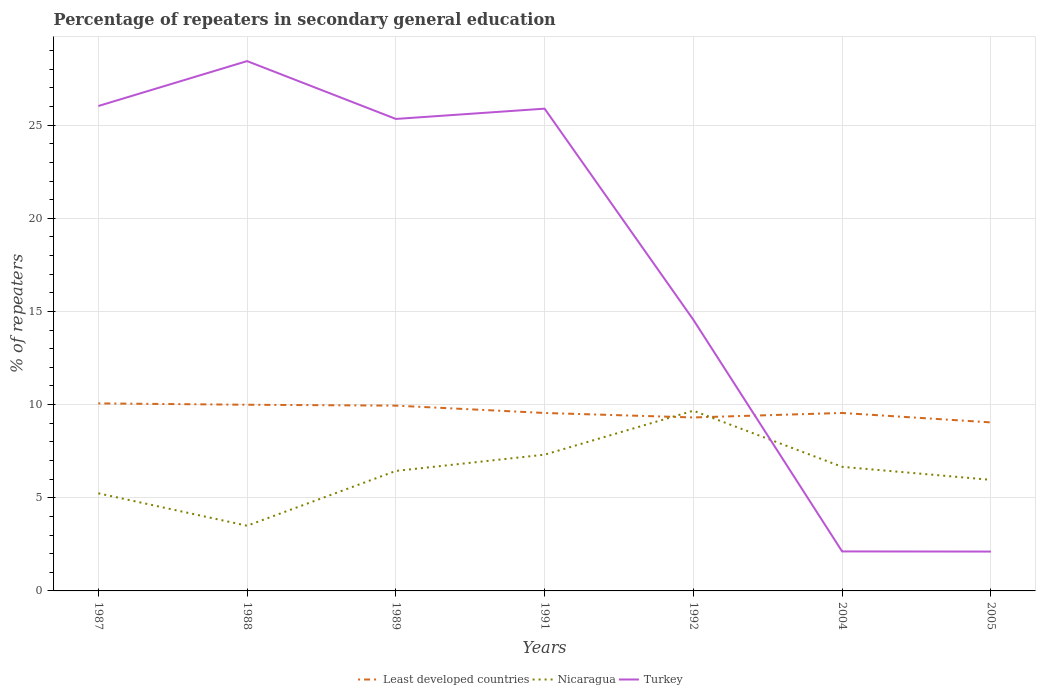How many different coloured lines are there?
Offer a very short reply. 3. Does the line corresponding to Least developed countries intersect with the line corresponding to Nicaragua?
Keep it short and to the point. Yes. Is the number of lines equal to the number of legend labels?
Provide a short and direct response. Yes. Across all years, what is the maximum percentage of repeaters in secondary general education in Turkey?
Your answer should be compact. 2.11. What is the total percentage of repeaters in secondary general education in Turkey in the graph?
Your response must be concise. 0.69. What is the difference between the highest and the second highest percentage of repeaters in secondary general education in Least developed countries?
Provide a short and direct response. 1.02. How many lines are there?
Offer a very short reply. 3. What is the difference between two consecutive major ticks on the Y-axis?
Your response must be concise. 5. Does the graph contain any zero values?
Offer a terse response. No. Does the graph contain grids?
Provide a short and direct response. Yes. Where does the legend appear in the graph?
Your response must be concise. Bottom center. What is the title of the graph?
Ensure brevity in your answer.  Percentage of repeaters in secondary general education. What is the label or title of the Y-axis?
Your answer should be compact. % of repeaters. What is the % of repeaters in Least developed countries in 1987?
Provide a succinct answer. 10.06. What is the % of repeaters of Nicaragua in 1987?
Provide a short and direct response. 5.24. What is the % of repeaters of Turkey in 1987?
Ensure brevity in your answer.  26.03. What is the % of repeaters of Least developed countries in 1988?
Make the answer very short. 9.99. What is the % of repeaters of Nicaragua in 1988?
Provide a succinct answer. 3.5. What is the % of repeaters of Turkey in 1988?
Give a very brief answer. 28.44. What is the % of repeaters in Least developed countries in 1989?
Provide a succinct answer. 9.94. What is the % of repeaters of Nicaragua in 1989?
Give a very brief answer. 6.44. What is the % of repeaters in Turkey in 1989?
Offer a terse response. 25.33. What is the % of repeaters of Least developed countries in 1991?
Your answer should be very brief. 9.55. What is the % of repeaters of Nicaragua in 1991?
Provide a short and direct response. 7.31. What is the % of repeaters in Turkey in 1991?
Offer a very short reply. 25.88. What is the % of repeaters in Least developed countries in 1992?
Offer a terse response. 9.31. What is the % of repeaters in Nicaragua in 1992?
Ensure brevity in your answer.  9.67. What is the % of repeaters of Turkey in 1992?
Provide a succinct answer. 14.55. What is the % of repeaters of Least developed countries in 2004?
Offer a very short reply. 9.55. What is the % of repeaters of Nicaragua in 2004?
Make the answer very short. 6.66. What is the % of repeaters of Turkey in 2004?
Your response must be concise. 2.12. What is the % of repeaters in Least developed countries in 2005?
Provide a short and direct response. 9.04. What is the % of repeaters in Nicaragua in 2005?
Make the answer very short. 5.96. What is the % of repeaters in Turkey in 2005?
Your answer should be very brief. 2.11. Across all years, what is the maximum % of repeaters of Least developed countries?
Your response must be concise. 10.06. Across all years, what is the maximum % of repeaters in Nicaragua?
Offer a terse response. 9.67. Across all years, what is the maximum % of repeaters in Turkey?
Provide a short and direct response. 28.44. Across all years, what is the minimum % of repeaters of Least developed countries?
Provide a short and direct response. 9.04. Across all years, what is the minimum % of repeaters in Nicaragua?
Your answer should be very brief. 3.5. Across all years, what is the minimum % of repeaters of Turkey?
Provide a succinct answer. 2.11. What is the total % of repeaters of Least developed countries in the graph?
Give a very brief answer. 67.46. What is the total % of repeaters of Nicaragua in the graph?
Your response must be concise. 44.78. What is the total % of repeaters of Turkey in the graph?
Ensure brevity in your answer.  124.46. What is the difference between the % of repeaters in Least developed countries in 1987 and that in 1988?
Give a very brief answer. 0.07. What is the difference between the % of repeaters of Nicaragua in 1987 and that in 1988?
Your answer should be compact. 1.74. What is the difference between the % of repeaters of Turkey in 1987 and that in 1988?
Give a very brief answer. -2.41. What is the difference between the % of repeaters in Least developed countries in 1987 and that in 1989?
Offer a terse response. 0.12. What is the difference between the % of repeaters of Nicaragua in 1987 and that in 1989?
Your answer should be compact. -1.2. What is the difference between the % of repeaters of Turkey in 1987 and that in 1989?
Your answer should be compact. 0.69. What is the difference between the % of repeaters of Least developed countries in 1987 and that in 1991?
Offer a very short reply. 0.51. What is the difference between the % of repeaters in Nicaragua in 1987 and that in 1991?
Your answer should be compact. -2.07. What is the difference between the % of repeaters in Turkey in 1987 and that in 1991?
Keep it short and to the point. 0.14. What is the difference between the % of repeaters of Least developed countries in 1987 and that in 1992?
Your answer should be compact. 0.75. What is the difference between the % of repeaters in Nicaragua in 1987 and that in 1992?
Your response must be concise. -4.43. What is the difference between the % of repeaters of Turkey in 1987 and that in 1992?
Provide a short and direct response. 11.47. What is the difference between the % of repeaters of Least developed countries in 1987 and that in 2004?
Keep it short and to the point. 0.51. What is the difference between the % of repeaters of Nicaragua in 1987 and that in 2004?
Make the answer very short. -1.42. What is the difference between the % of repeaters of Turkey in 1987 and that in 2004?
Offer a terse response. 23.91. What is the difference between the % of repeaters in Least developed countries in 1987 and that in 2005?
Provide a succinct answer. 1.02. What is the difference between the % of repeaters of Nicaragua in 1987 and that in 2005?
Your answer should be compact. -0.72. What is the difference between the % of repeaters in Turkey in 1987 and that in 2005?
Keep it short and to the point. 23.91. What is the difference between the % of repeaters of Least developed countries in 1988 and that in 1989?
Offer a terse response. 0.05. What is the difference between the % of repeaters in Nicaragua in 1988 and that in 1989?
Your answer should be compact. -2.94. What is the difference between the % of repeaters of Turkey in 1988 and that in 1989?
Provide a succinct answer. 3.1. What is the difference between the % of repeaters in Least developed countries in 1988 and that in 1991?
Ensure brevity in your answer.  0.44. What is the difference between the % of repeaters of Nicaragua in 1988 and that in 1991?
Offer a very short reply. -3.81. What is the difference between the % of repeaters in Turkey in 1988 and that in 1991?
Your response must be concise. 2.55. What is the difference between the % of repeaters of Least developed countries in 1988 and that in 1992?
Provide a succinct answer. 0.68. What is the difference between the % of repeaters of Nicaragua in 1988 and that in 1992?
Give a very brief answer. -6.17. What is the difference between the % of repeaters of Turkey in 1988 and that in 1992?
Give a very brief answer. 13.88. What is the difference between the % of repeaters in Least developed countries in 1988 and that in 2004?
Your answer should be compact. 0.44. What is the difference between the % of repeaters of Nicaragua in 1988 and that in 2004?
Your answer should be very brief. -3.16. What is the difference between the % of repeaters in Turkey in 1988 and that in 2004?
Ensure brevity in your answer.  26.32. What is the difference between the % of repeaters in Least developed countries in 1988 and that in 2005?
Provide a short and direct response. 0.95. What is the difference between the % of repeaters of Nicaragua in 1988 and that in 2005?
Your answer should be very brief. -2.46. What is the difference between the % of repeaters of Turkey in 1988 and that in 2005?
Provide a succinct answer. 26.32. What is the difference between the % of repeaters of Least developed countries in 1989 and that in 1991?
Keep it short and to the point. 0.39. What is the difference between the % of repeaters in Nicaragua in 1989 and that in 1991?
Provide a succinct answer. -0.87. What is the difference between the % of repeaters in Turkey in 1989 and that in 1991?
Your response must be concise. -0.55. What is the difference between the % of repeaters of Least developed countries in 1989 and that in 1992?
Offer a very short reply. 0.63. What is the difference between the % of repeaters of Nicaragua in 1989 and that in 1992?
Offer a very short reply. -3.23. What is the difference between the % of repeaters of Turkey in 1989 and that in 1992?
Keep it short and to the point. 10.78. What is the difference between the % of repeaters of Least developed countries in 1989 and that in 2004?
Provide a short and direct response. 0.39. What is the difference between the % of repeaters in Nicaragua in 1989 and that in 2004?
Give a very brief answer. -0.22. What is the difference between the % of repeaters in Turkey in 1989 and that in 2004?
Offer a terse response. 23.21. What is the difference between the % of repeaters in Least developed countries in 1989 and that in 2005?
Provide a short and direct response. 0.9. What is the difference between the % of repeaters of Nicaragua in 1989 and that in 2005?
Your answer should be very brief. 0.48. What is the difference between the % of repeaters in Turkey in 1989 and that in 2005?
Ensure brevity in your answer.  23.22. What is the difference between the % of repeaters of Least developed countries in 1991 and that in 1992?
Offer a very short reply. 0.24. What is the difference between the % of repeaters of Nicaragua in 1991 and that in 1992?
Provide a short and direct response. -2.36. What is the difference between the % of repeaters of Turkey in 1991 and that in 1992?
Provide a short and direct response. 11.33. What is the difference between the % of repeaters of Least developed countries in 1991 and that in 2004?
Your response must be concise. -0. What is the difference between the % of repeaters in Nicaragua in 1991 and that in 2004?
Provide a short and direct response. 0.65. What is the difference between the % of repeaters of Turkey in 1991 and that in 2004?
Your answer should be very brief. 23.76. What is the difference between the % of repeaters of Least developed countries in 1991 and that in 2005?
Offer a very short reply. 0.51. What is the difference between the % of repeaters of Nicaragua in 1991 and that in 2005?
Provide a succinct answer. 1.35. What is the difference between the % of repeaters of Turkey in 1991 and that in 2005?
Ensure brevity in your answer.  23.77. What is the difference between the % of repeaters in Least developed countries in 1992 and that in 2004?
Ensure brevity in your answer.  -0.24. What is the difference between the % of repeaters in Nicaragua in 1992 and that in 2004?
Make the answer very short. 3.01. What is the difference between the % of repeaters of Turkey in 1992 and that in 2004?
Keep it short and to the point. 12.43. What is the difference between the % of repeaters in Least developed countries in 1992 and that in 2005?
Offer a very short reply. 0.27. What is the difference between the % of repeaters of Nicaragua in 1992 and that in 2005?
Ensure brevity in your answer.  3.71. What is the difference between the % of repeaters of Turkey in 1992 and that in 2005?
Your answer should be very brief. 12.44. What is the difference between the % of repeaters of Least developed countries in 2004 and that in 2005?
Give a very brief answer. 0.51. What is the difference between the % of repeaters of Nicaragua in 2004 and that in 2005?
Your answer should be compact. 0.7. What is the difference between the % of repeaters in Turkey in 2004 and that in 2005?
Your answer should be compact. 0.01. What is the difference between the % of repeaters of Least developed countries in 1987 and the % of repeaters of Nicaragua in 1988?
Your response must be concise. 6.57. What is the difference between the % of repeaters in Least developed countries in 1987 and the % of repeaters in Turkey in 1988?
Offer a very short reply. -18.37. What is the difference between the % of repeaters of Nicaragua in 1987 and the % of repeaters of Turkey in 1988?
Give a very brief answer. -23.2. What is the difference between the % of repeaters of Least developed countries in 1987 and the % of repeaters of Nicaragua in 1989?
Ensure brevity in your answer.  3.63. What is the difference between the % of repeaters of Least developed countries in 1987 and the % of repeaters of Turkey in 1989?
Offer a very short reply. -15.27. What is the difference between the % of repeaters in Nicaragua in 1987 and the % of repeaters in Turkey in 1989?
Your response must be concise. -20.09. What is the difference between the % of repeaters in Least developed countries in 1987 and the % of repeaters in Nicaragua in 1991?
Offer a terse response. 2.75. What is the difference between the % of repeaters in Least developed countries in 1987 and the % of repeaters in Turkey in 1991?
Your answer should be very brief. -15.82. What is the difference between the % of repeaters in Nicaragua in 1987 and the % of repeaters in Turkey in 1991?
Ensure brevity in your answer.  -20.64. What is the difference between the % of repeaters of Least developed countries in 1987 and the % of repeaters of Nicaragua in 1992?
Provide a succinct answer. 0.39. What is the difference between the % of repeaters of Least developed countries in 1987 and the % of repeaters of Turkey in 1992?
Make the answer very short. -4.49. What is the difference between the % of repeaters in Nicaragua in 1987 and the % of repeaters in Turkey in 1992?
Your response must be concise. -9.31. What is the difference between the % of repeaters of Least developed countries in 1987 and the % of repeaters of Nicaragua in 2004?
Offer a very short reply. 3.4. What is the difference between the % of repeaters of Least developed countries in 1987 and the % of repeaters of Turkey in 2004?
Your response must be concise. 7.94. What is the difference between the % of repeaters of Nicaragua in 1987 and the % of repeaters of Turkey in 2004?
Offer a terse response. 3.12. What is the difference between the % of repeaters in Least developed countries in 1987 and the % of repeaters in Nicaragua in 2005?
Offer a very short reply. 4.1. What is the difference between the % of repeaters in Least developed countries in 1987 and the % of repeaters in Turkey in 2005?
Offer a very short reply. 7.95. What is the difference between the % of repeaters of Nicaragua in 1987 and the % of repeaters of Turkey in 2005?
Offer a terse response. 3.13. What is the difference between the % of repeaters in Least developed countries in 1988 and the % of repeaters in Nicaragua in 1989?
Offer a terse response. 3.55. What is the difference between the % of repeaters in Least developed countries in 1988 and the % of repeaters in Turkey in 1989?
Keep it short and to the point. -15.34. What is the difference between the % of repeaters of Nicaragua in 1988 and the % of repeaters of Turkey in 1989?
Give a very brief answer. -21.83. What is the difference between the % of repeaters of Least developed countries in 1988 and the % of repeaters of Nicaragua in 1991?
Ensure brevity in your answer.  2.68. What is the difference between the % of repeaters in Least developed countries in 1988 and the % of repeaters in Turkey in 1991?
Your answer should be very brief. -15.89. What is the difference between the % of repeaters in Nicaragua in 1988 and the % of repeaters in Turkey in 1991?
Your answer should be very brief. -22.38. What is the difference between the % of repeaters in Least developed countries in 1988 and the % of repeaters in Nicaragua in 1992?
Make the answer very short. 0.32. What is the difference between the % of repeaters of Least developed countries in 1988 and the % of repeaters of Turkey in 1992?
Keep it short and to the point. -4.56. What is the difference between the % of repeaters in Nicaragua in 1988 and the % of repeaters in Turkey in 1992?
Offer a terse response. -11.05. What is the difference between the % of repeaters in Least developed countries in 1988 and the % of repeaters in Nicaragua in 2004?
Provide a short and direct response. 3.33. What is the difference between the % of repeaters of Least developed countries in 1988 and the % of repeaters of Turkey in 2004?
Your response must be concise. 7.87. What is the difference between the % of repeaters of Nicaragua in 1988 and the % of repeaters of Turkey in 2004?
Give a very brief answer. 1.38. What is the difference between the % of repeaters of Least developed countries in 1988 and the % of repeaters of Nicaragua in 2005?
Provide a succinct answer. 4.03. What is the difference between the % of repeaters of Least developed countries in 1988 and the % of repeaters of Turkey in 2005?
Offer a very short reply. 7.88. What is the difference between the % of repeaters in Nicaragua in 1988 and the % of repeaters in Turkey in 2005?
Make the answer very short. 1.39. What is the difference between the % of repeaters in Least developed countries in 1989 and the % of repeaters in Nicaragua in 1991?
Provide a short and direct response. 2.63. What is the difference between the % of repeaters in Least developed countries in 1989 and the % of repeaters in Turkey in 1991?
Your answer should be compact. -15.94. What is the difference between the % of repeaters in Nicaragua in 1989 and the % of repeaters in Turkey in 1991?
Provide a succinct answer. -19.44. What is the difference between the % of repeaters of Least developed countries in 1989 and the % of repeaters of Nicaragua in 1992?
Provide a succinct answer. 0.27. What is the difference between the % of repeaters in Least developed countries in 1989 and the % of repeaters in Turkey in 1992?
Ensure brevity in your answer.  -4.61. What is the difference between the % of repeaters in Nicaragua in 1989 and the % of repeaters in Turkey in 1992?
Give a very brief answer. -8.11. What is the difference between the % of repeaters in Least developed countries in 1989 and the % of repeaters in Nicaragua in 2004?
Give a very brief answer. 3.28. What is the difference between the % of repeaters in Least developed countries in 1989 and the % of repeaters in Turkey in 2004?
Provide a succinct answer. 7.82. What is the difference between the % of repeaters in Nicaragua in 1989 and the % of repeaters in Turkey in 2004?
Provide a succinct answer. 4.32. What is the difference between the % of repeaters in Least developed countries in 1989 and the % of repeaters in Nicaragua in 2005?
Ensure brevity in your answer.  3.98. What is the difference between the % of repeaters in Least developed countries in 1989 and the % of repeaters in Turkey in 2005?
Offer a very short reply. 7.83. What is the difference between the % of repeaters in Nicaragua in 1989 and the % of repeaters in Turkey in 2005?
Provide a short and direct response. 4.33. What is the difference between the % of repeaters of Least developed countries in 1991 and the % of repeaters of Nicaragua in 1992?
Provide a short and direct response. -0.12. What is the difference between the % of repeaters in Least developed countries in 1991 and the % of repeaters in Turkey in 1992?
Your answer should be very brief. -5. What is the difference between the % of repeaters in Nicaragua in 1991 and the % of repeaters in Turkey in 1992?
Make the answer very short. -7.24. What is the difference between the % of repeaters in Least developed countries in 1991 and the % of repeaters in Nicaragua in 2004?
Ensure brevity in your answer.  2.89. What is the difference between the % of repeaters of Least developed countries in 1991 and the % of repeaters of Turkey in 2004?
Offer a terse response. 7.43. What is the difference between the % of repeaters in Nicaragua in 1991 and the % of repeaters in Turkey in 2004?
Your answer should be compact. 5.19. What is the difference between the % of repeaters in Least developed countries in 1991 and the % of repeaters in Nicaragua in 2005?
Ensure brevity in your answer.  3.59. What is the difference between the % of repeaters of Least developed countries in 1991 and the % of repeaters of Turkey in 2005?
Your answer should be very brief. 7.44. What is the difference between the % of repeaters of Least developed countries in 1992 and the % of repeaters of Nicaragua in 2004?
Provide a short and direct response. 2.65. What is the difference between the % of repeaters in Least developed countries in 1992 and the % of repeaters in Turkey in 2004?
Your answer should be very brief. 7.19. What is the difference between the % of repeaters of Nicaragua in 1992 and the % of repeaters of Turkey in 2004?
Provide a succinct answer. 7.55. What is the difference between the % of repeaters in Least developed countries in 1992 and the % of repeaters in Nicaragua in 2005?
Ensure brevity in your answer.  3.35. What is the difference between the % of repeaters in Least developed countries in 1992 and the % of repeaters in Turkey in 2005?
Your answer should be very brief. 7.2. What is the difference between the % of repeaters in Nicaragua in 1992 and the % of repeaters in Turkey in 2005?
Your answer should be very brief. 7.56. What is the difference between the % of repeaters of Least developed countries in 2004 and the % of repeaters of Nicaragua in 2005?
Provide a short and direct response. 3.59. What is the difference between the % of repeaters of Least developed countries in 2004 and the % of repeaters of Turkey in 2005?
Provide a short and direct response. 7.44. What is the difference between the % of repeaters in Nicaragua in 2004 and the % of repeaters in Turkey in 2005?
Offer a terse response. 4.55. What is the average % of repeaters of Least developed countries per year?
Provide a succinct answer. 9.64. What is the average % of repeaters in Nicaragua per year?
Keep it short and to the point. 6.4. What is the average % of repeaters in Turkey per year?
Provide a succinct answer. 17.78. In the year 1987, what is the difference between the % of repeaters in Least developed countries and % of repeaters in Nicaragua?
Give a very brief answer. 4.83. In the year 1987, what is the difference between the % of repeaters in Least developed countries and % of repeaters in Turkey?
Make the answer very short. -15.96. In the year 1987, what is the difference between the % of repeaters of Nicaragua and % of repeaters of Turkey?
Provide a succinct answer. -20.79. In the year 1988, what is the difference between the % of repeaters of Least developed countries and % of repeaters of Nicaragua?
Provide a short and direct response. 6.49. In the year 1988, what is the difference between the % of repeaters in Least developed countries and % of repeaters in Turkey?
Give a very brief answer. -18.44. In the year 1988, what is the difference between the % of repeaters in Nicaragua and % of repeaters in Turkey?
Provide a short and direct response. -24.94. In the year 1989, what is the difference between the % of repeaters in Least developed countries and % of repeaters in Nicaragua?
Ensure brevity in your answer.  3.5. In the year 1989, what is the difference between the % of repeaters of Least developed countries and % of repeaters of Turkey?
Provide a short and direct response. -15.39. In the year 1989, what is the difference between the % of repeaters of Nicaragua and % of repeaters of Turkey?
Your response must be concise. -18.89. In the year 1991, what is the difference between the % of repeaters in Least developed countries and % of repeaters in Nicaragua?
Provide a short and direct response. 2.24. In the year 1991, what is the difference between the % of repeaters of Least developed countries and % of repeaters of Turkey?
Offer a terse response. -16.33. In the year 1991, what is the difference between the % of repeaters in Nicaragua and % of repeaters in Turkey?
Offer a terse response. -18.57. In the year 1992, what is the difference between the % of repeaters in Least developed countries and % of repeaters in Nicaragua?
Offer a terse response. -0.36. In the year 1992, what is the difference between the % of repeaters in Least developed countries and % of repeaters in Turkey?
Give a very brief answer. -5.24. In the year 1992, what is the difference between the % of repeaters in Nicaragua and % of repeaters in Turkey?
Your answer should be very brief. -4.88. In the year 2004, what is the difference between the % of repeaters in Least developed countries and % of repeaters in Nicaragua?
Your response must be concise. 2.89. In the year 2004, what is the difference between the % of repeaters of Least developed countries and % of repeaters of Turkey?
Offer a very short reply. 7.43. In the year 2004, what is the difference between the % of repeaters of Nicaragua and % of repeaters of Turkey?
Give a very brief answer. 4.54. In the year 2005, what is the difference between the % of repeaters in Least developed countries and % of repeaters in Nicaragua?
Give a very brief answer. 3.08. In the year 2005, what is the difference between the % of repeaters in Least developed countries and % of repeaters in Turkey?
Give a very brief answer. 6.93. In the year 2005, what is the difference between the % of repeaters of Nicaragua and % of repeaters of Turkey?
Ensure brevity in your answer.  3.85. What is the ratio of the % of repeaters in Least developed countries in 1987 to that in 1988?
Ensure brevity in your answer.  1.01. What is the ratio of the % of repeaters in Nicaragua in 1987 to that in 1988?
Offer a terse response. 1.5. What is the ratio of the % of repeaters in Turkey in 1987 to that in 1988?
Your answer should be compact. 0.92. What is the ratio of the % of repeaters of Least developed countries in 1987 to that in 1989?
Ensure brevity in your answer.  1.01. What is the ratio of the % of repeaters in Nicaragua in 1987 to that in 1989?
Provide a succinct answer. 0.81. What is the ratio of the % of repeaters of Turkey in 1987 to that in 1989?
Provide a short and direct response. 1.03. What is the ratio of the % of repeaters in Least developed countries in 1987 to that in 1991?
Make the answer very short. 1.05. What is the ratio of the % of repeaters of Nicaragua in 1987 to that in 1991?
Keep it short and to the point. 0.72. What is the ratio of the % of repeaters in Least developed countries in 1987 to that in 1992?
Give a very brief answer. 1.08. What is the ratio of the % of repeaters in Nicaragua in 1987 to that in 1992?
Ensure brevity in your answer.  0.54. What is the ratio of the % of repeaters of Turkey in 1987 to that in 1992?
Your answer should be very brief. 1.79. What is the ratio of the % of repeaters in Least developed countries in 1987 to that in 2004?
Provide a short and direct response. 1.05. What is the ratio of the % of repeaters in Nicaragua in 1987 to that in 2004?
Your response must be concise. 0.79. What is the ratio of the % of repeaters of Turkey in 1987 to that in 2004?
Offer a terse response. 12.28. What is the ratio of the % of repeaters of Least developed countries in 1987 to that in 2005?
Keep it short and to the point. 1.11. What is the ratio of the % of repeaters in Nicaragua in 1987 to that in 2005?
Offer a very short reply. 0.88. What is the ratio of the % of repeaters of Turkey in 1987 to that in 2005?
Provide a short and direct response. 12.32. What is the ratio of the % of repeaters of Least developed countries in 1988 to that in 1989?
Your answer should be very brief. 1. What is the ratio of the % of repeaters in Nicaragua in 1988 to that in 1989?
Offer a very short reply. 0.54. What is the ratio of the % of repeaters of Turkey in 1988 to that in 1989?
Make the answer very short. 1.12. What is the ratio of the % of repeaters of Least developed countries in 1988 to that in 1991?
Provide a short and direct response. 1.05. What is the ratio of the % of repeaters of Nicaragua in 1988 to that in 1991?
Ensure brevity in your answer.  0.48. What is the ratio of the % of repeaters of Turkey in 1988 to that in 1991?
Offer a terse response. 1.1. What is the ratio of the % of repeaters in Least developed countries in 1988 to that in 1992?
Make the answer very short. 1.07. What is the ratio of the % of repeaters in Nicaragua in 1988 to that in 1992?
Make the answer very short. 0.36. What is the ratio of the % of repeaters of Turkey in 1988 to that in 1992?
Your answer should be very brief. 1.95. What is the ratio of the % of repeaters in Least developed countries in 1988 to that in 2004?
Provide a short and direct response. 1.05. What is the ratio of the % of repeaters of Nicaragua in 1988 to that in 2004?
Your answer should be very brief. 0.53. What is the ratio of the % of repeaters in Turkey in 1988 to that in 2004?
Keep it short and to the point. 13.41. What is the ratio of the % of repeaters of Least developed countries in 1988 to that in 2005?
Offer a terse response. 1.1. What is the ratio of the % of repeaters in Nicaragua in 1988 to that in 2005?
Give a very brief answer. 0.59. What is the ratio of the % of repeaters in Turkey in 1988 to that in 2005?
Ensure brevity in your answer.  13.46. What is the ratio of the % of repeaters in Least developed countries in 1989 to that in 1991?
Your response must be concise. 1.04. What is the ratio of the % of repeaters in Nicaragua in 1989 to that in 1991?
Your answer should be compact. 0.88. What is the ratio of the % of repeaters in Turkey in 1989 to that in 1991?
Provide a short and direct response. 0.98. What is the ratio of the % of repeaters of Least developed countries in 1989 to that in 1992?
Make the answer very short. 1.07. What is the ratio of the % of repeaters in Nicaragua in 1989 to that in 1992?
Offer a terse response. 0.67. What is the ratio of the % of repeaters in Turkey in 1989 to that in 1992?
Offer a very short reply. 1.74. What is the ratio of the % of repeaters in Least developed countries in 1989 to that in 2004?
Give a very brief answer. 1.04. What is the ratio of the % of repeaters in Nicaragua in 1989 to that in 2004?
Offer a terse response. 0.97. What is the ratio of the % of repeaters of Turkey in 1989 to that in 2004?
Offer a very short reply. 11.95. What is the ratio of the % of repeaters in Least developed countries in 1989 to that in 2005?
Give a very brief answer. 1.1. What is the ratio of the % of repeaters in Nicaragua in 1989 to that in 2005?
Offer a very short reply. 1.08. What is the ratio of the % of repeaters of Turkey in 1989 to that in 2005?
Give a very brief answer. 11.99. What is the ratio of the % of repeaters in Least developed countries in 1991 to that in 1992?
Offer a very short reply. 1.03. What is the ratio of the % of repeaters of Nicaragua in 1991 to that in 1992?
Ensure brevity in your answer.  0.76. What is the ratio of the % of repeaters in Turkey in 1991 to that in 1992?
Give a very brief answer. 1.78. What is the ratio of the % of repeaters in Least developed countries in 1991 to that in 2004?
Your answer should be very brief. 1. What is the ratio of the % of repeaters in Nicaragua in 1991 to that in 2004?
Your response must be concise. 1.1. What is the ratio of the % of repeaters in Turkey in 1991 to that in 2004?
Offer a very short reply. 12.21. What is the ratio of the % of repeaters in Least developed countries in 1991 to that in 2005?
Give a very brief answer. 1.06. What is the ratio of the % of repeaters of Nicaragua in 1991 to that in 2005?
Make the answer very short. 1.23. What is the ratio of the % of repeaters of Turkey in 1991 to that in 2005?
Your response must be concise. 12.25. What is the ratio of the % of repeaters of Least developed countries in 1992 to that in 2004?
Offer a very short reply. 0.97. What is the ratio of the % of repeaters of Nicaragua in 1992 to that in 2004?
Provide a short and direct response. 1.45. What is the ratio of the % of repeaters in Turkey in 1992 to that in 2004?
Keep it short and to the point. 6.87. What is the ratio of the % of repeaters in Least developed countries in 1992 to that in 2005?
Offer a terse response. 1.03. What is the ratio of the % of repeaters in Nicaragua in 1992 to that in 2005?
Make the answer very short. 1.62. What is the ratio of the % of repeaters in Turkey in 1992 to that in 2005?
Your answer should be compact. 6.89. What is the ratio of the % of repeaters of Least developed countries in 2004 to that in 2005?
Make the answer very short. 1.06. What is the ratio of the % of repeaters of Nicaragua in 2004 to that in 2005?
Provide a succinct answer. 1.12. What is the difference between the highest and the second highest % of repeaters in Least developed countries?
Give a very brief answer. 0.07. What is the difference between the highest and the second highest % of repeaters in Nicaragua?
Your answer should be compact. 2.36. What is the difference between the highest and the second highest % of repeaters in Turkey?
Offer a very short reply. 2.41. What is the difference between the highest and the lowest % of repeaters of Least developed countries?
Keep it short and to the point. 1.02. What is the difference between the highest and the lowest % of repeaters in Nicaragua?
Offer a terse response. 6.17. What is the difference between the highest and the lowest % of repeaters of Turkey?
Your response must be concise. 26.32. 